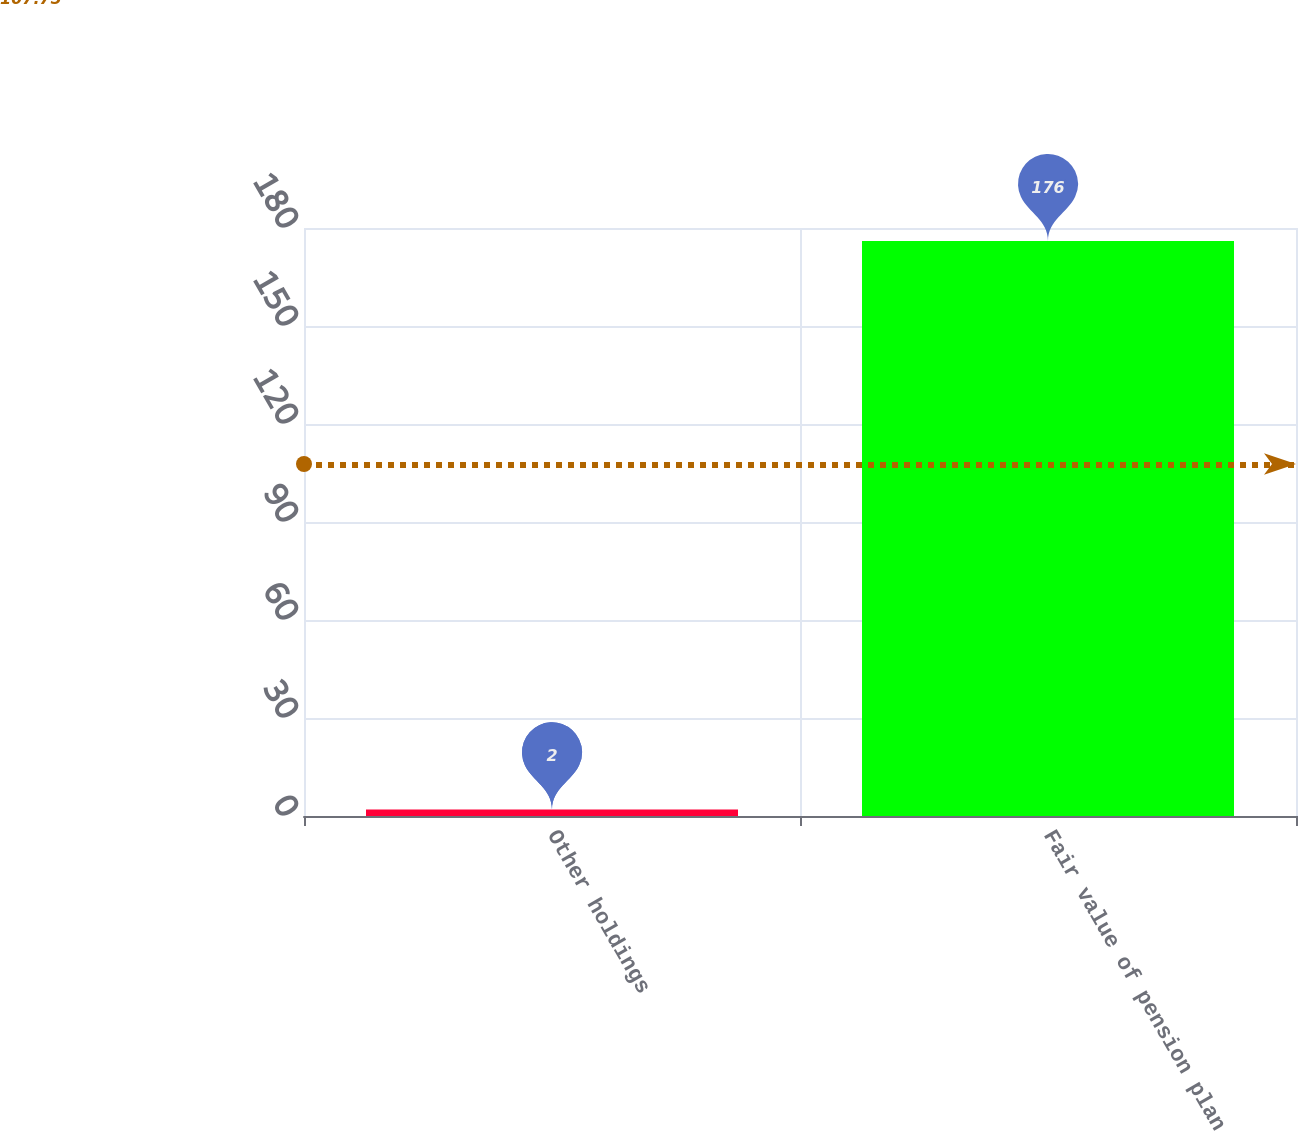Convert chart. <chart><loc_0><loc_0><loc_500><loc_500><bar_chart><fcel>Other holdings<fcel>Fair value of pension plan<nl><fcel>2<fcel>176<nl></chart> 